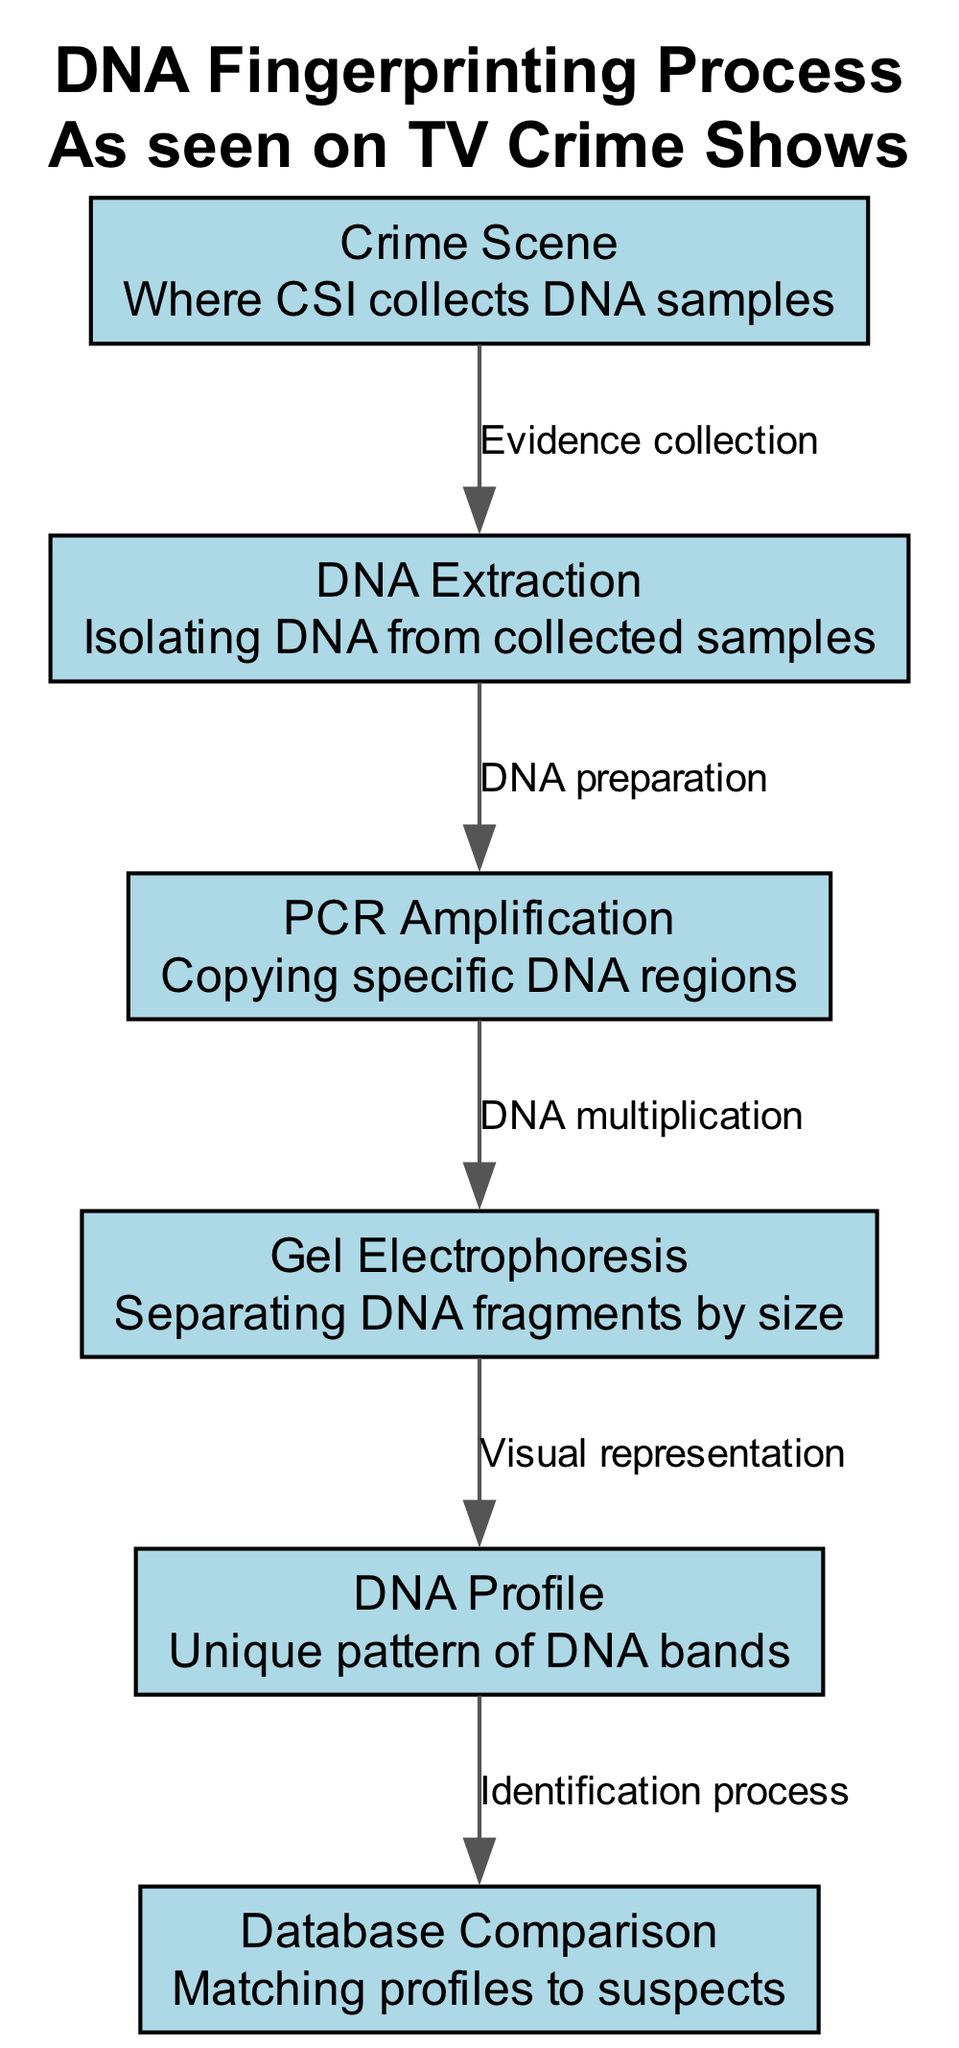What is the first step in the DNA fingerprinting process? The diagram shows that the first node is "Crime Scene," which indicates that it is the starting point where DNA samples are collected for analysis.
Answer: Crime Scene How many nodes are present in the diagram? Counting the nodes displayed in the diagram, there are six distinct nodes that detail each step of the DNA fingerprinting process.
Answer: 6 What type of process occurs between "DNA Extraction" and "PCR Amplification"? The edge connecting these two nodes is labeled "DNA preparation," indicating that this particular process involves preparing the DNA for amplification.
Answer: DNA preparation What does the "Gel Electrophoresis" step achieve? The description associated with the "Gel Electrophoresis" node explains that it separates DNA fragments based on size, which is a key step in analyzing DNA.
Answer: Separating DNA fragments by size Which step follows "DNA Profile" in the process? The diagram indicates that there is an edge labeled "Identification process" that connects "DNA Profile" to "Database Comparison," showing that the next step after creating a DNA profile is matching it to a database of suspects.
Answer: Database Comparison How does "PCR Amplification" relate to "DNA Extraction"? The relationship is shown in the diagram by an edge labeled "DNA preparation" connecting "DNA Extraction" to "PCR Amplification," meaning that the extracted DNA needs to be prepared before amplification can take place.
Answer: DNA preparation What is the outcome of "Gel Electrophoresis"? The outcome is represented in the node "DNA Profile," which indicates that the visual representation obtained after conducting gel electrophoresis results in a unique pattern of DNA bands that can be analyzed.
Answer: Unique pattern of DNA bands How are DNA profiles utilized in the forensic investigation process? The flow from "DNA Profile" to "Database Comparison" indicates that these profiles are critical for matching with potential suspects in a database during the identification process.
Answer: Matching profiles to suspects 